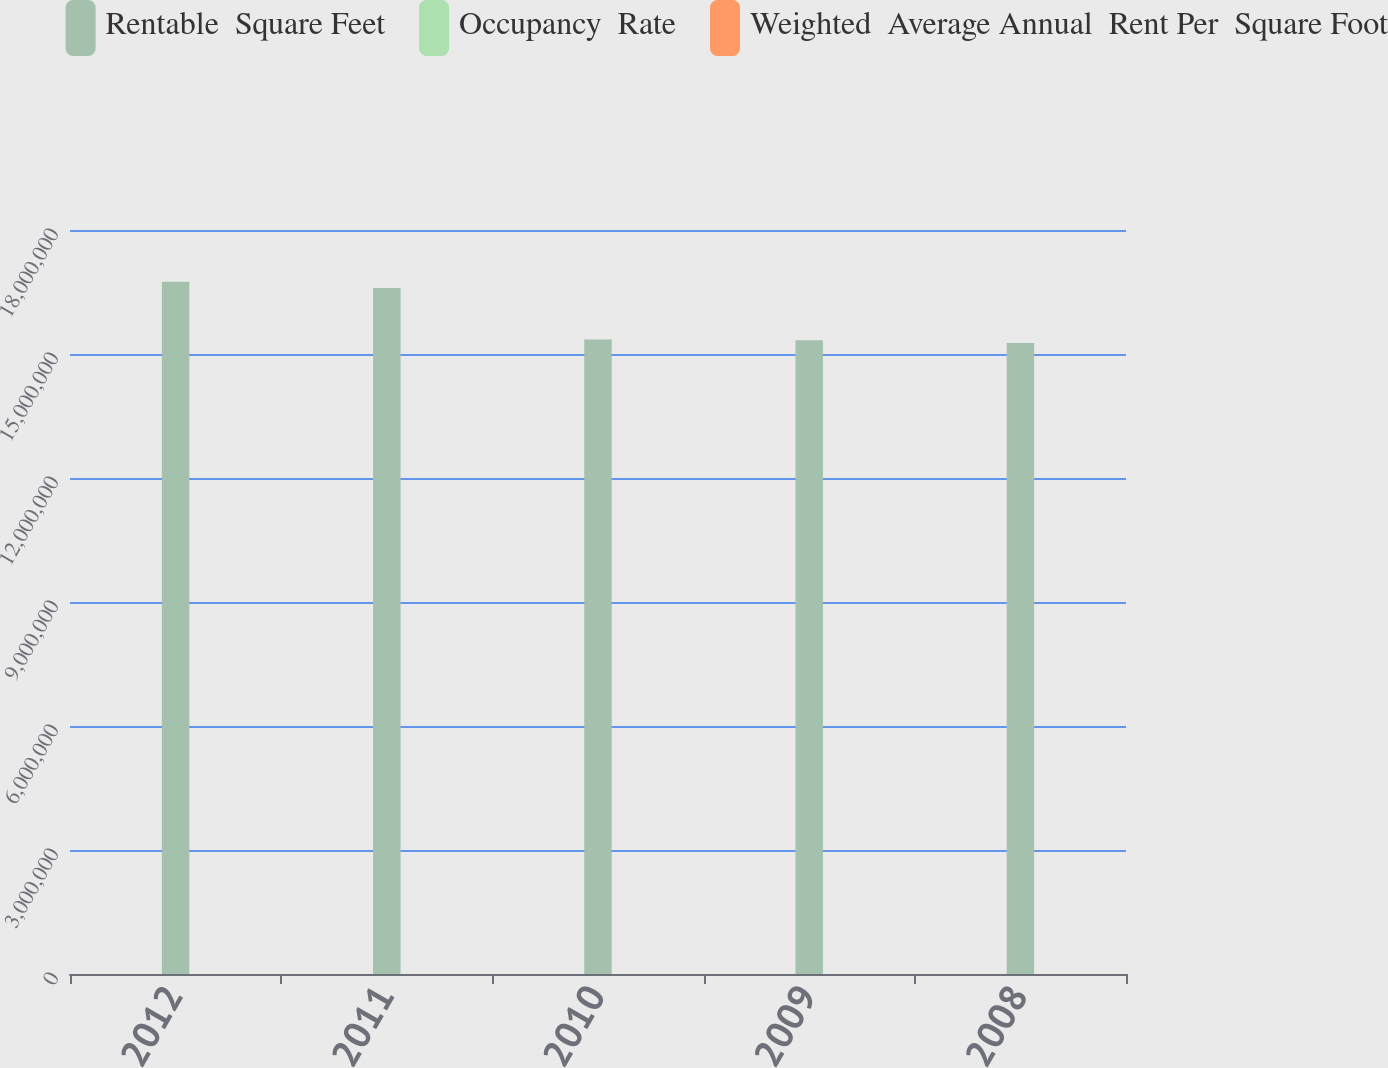<chart> <loc_0><loc_0><loc_500><loc_500><stacked_bar_chart><ecel><fcel>2012<fcel>2011<fcel>2010<fcel>2009<fcel>2008<nl><fcel>Rentable  Square Feet<fcel>1.6751e+07<fcel>1.6598e+07<fcel>1.5348e+07<fcel>1.5331e+07<fcel>1.5266e+07<nl><fcel>Occupancy  Rate<fcel>95.9<fcel>96.2<fcel>96.1<fcel>97.1<fcel>98<nl><fcel>Weighted  Average Annual  Rent Per  Square Foot<fcel>60.17<fcel>58.7<fcel>56.14<fcel>55.54<fcel>55<nl></chart> 